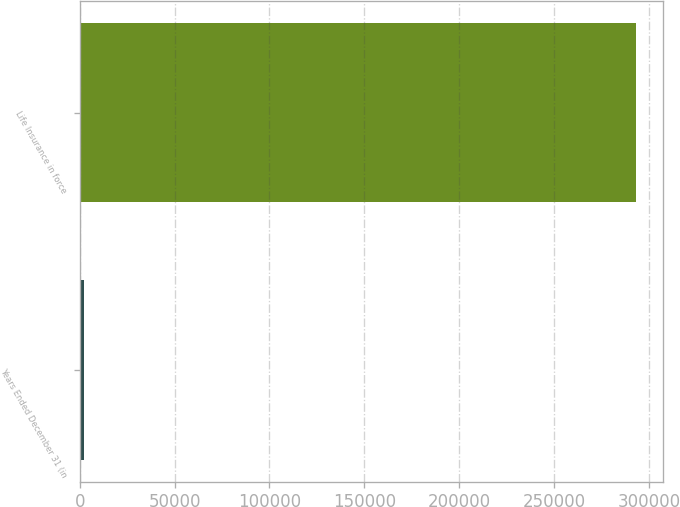Convert chart to OTSL. <chart><loc_0><loc_0><loc_500><loc_500><bar_chart><fcel>Years Ended December 31 (in<fcel>Life Insurance in force<nl><fcel>2003<fcel>293064<nl></chart> 